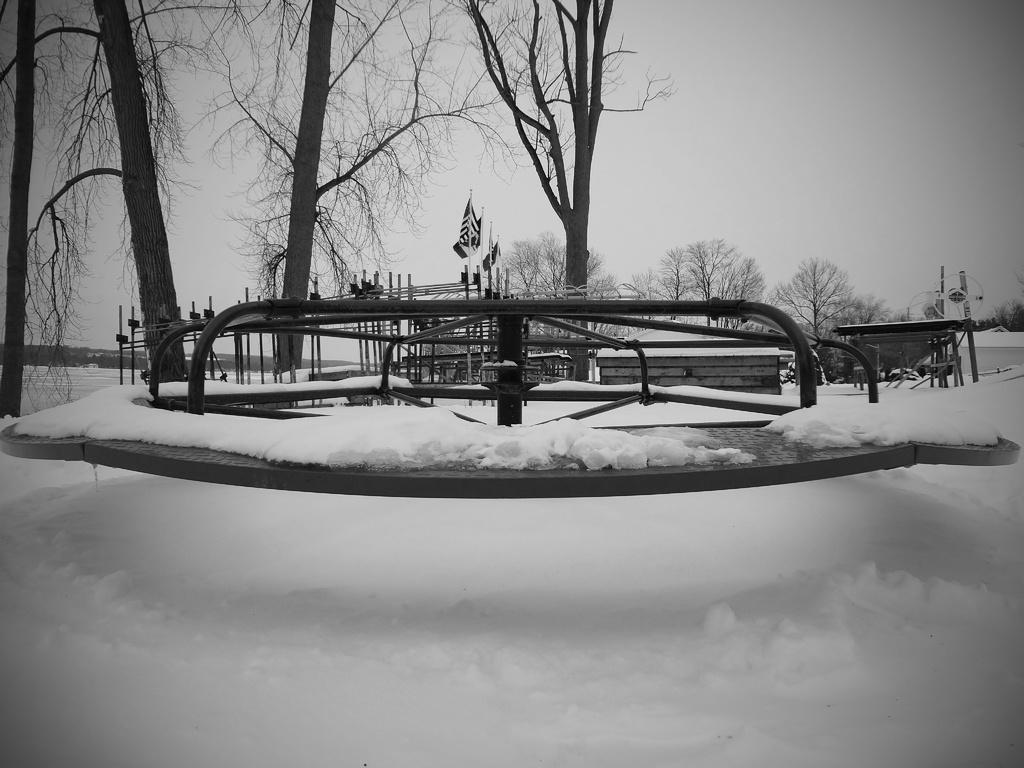How would you summarize this image in a sentence or two? It is the snow at the bottom, these are the trees. At the top it is the sky. This is the black and white image. 